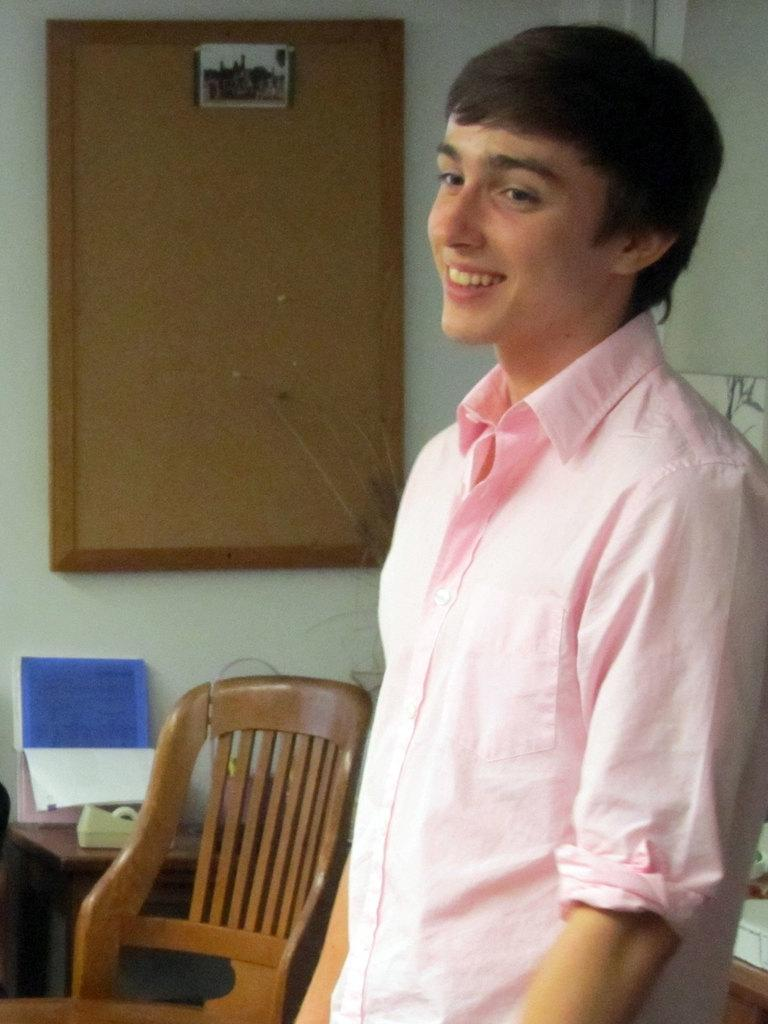What is the person in the image doing? The person is standing and smiling in the image. What objects can be seen in the background of the image? There is a chair, a table, a calendar, and a notice board on the wall in the background of the image. What type of bait is the person using to catch fish in the image? There is no indication of fishing or bait in the image; the person is standing and smiling. What event is being advertised on the notice board in the image? There is no event being advertised on the notice board in the image; we can only see that there is a notice board on the wall. 